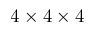Convert formula to latex. <formula><loc_0><loc_0><loc_500><loc_500>4 \times 4 \times 4</formula> 